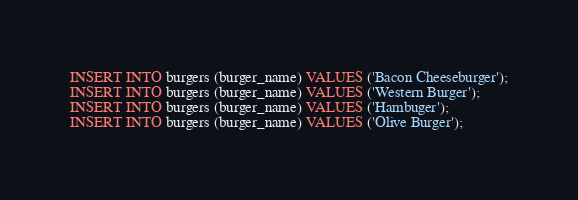Convert code to text. <code><loc_0><loc_0><loc_500><loc_500><_SQL_>
INSERT INTO burgers (burger_name) VALUES ('Bacon Cheeseburger');
INSERT INTO burgers (burger_name) VALUES ('Western Burger');
INSERT INTO burgers (burger_name) VALUES ('Hambuger');
INSERT INTO burgers (burger_name) VALUES ('Olive Burger');

</code> 